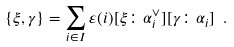<formula> <loc_0><loc_0><loc_500><loc_500>\{ \xi , \gamma \} = \sum _ { i \in I } \varepsilon ( i ) [ \xi \colon \alpha _ { i } ^ { \vee } ] [ \gamma \colon \alpha _ { i } ] \ .</formula> 